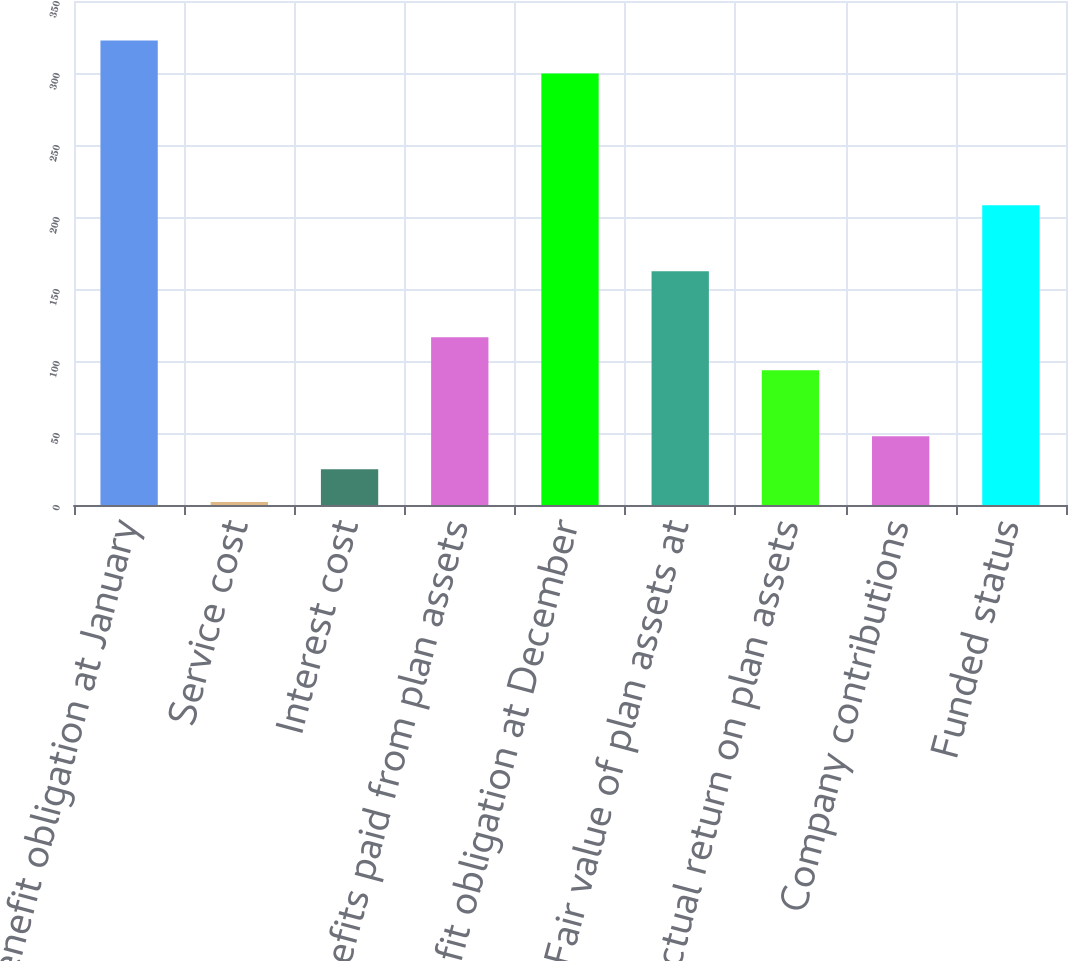Convert chart. <chart><loc_0><loc_0><loc_500><loc_500><bar_chart><fcel>Benefit obligation at January<fcel>Service cost<fcel>Interest cost<fcel>Benefits paid from plan assets<fcel>Benefit obligation at December<fcel>Fair value of plan assets at<fcel>Actual return on plan assets<fcel>Company contributions<fcel>Funded status<nl><fcel>322.6<fcel>2<fcel>24.9<fcel>116.5<fcel>299.7<fcel>162.3<fcel>93.6<fcel>47.8<fcel>208.1<nl></chart> 